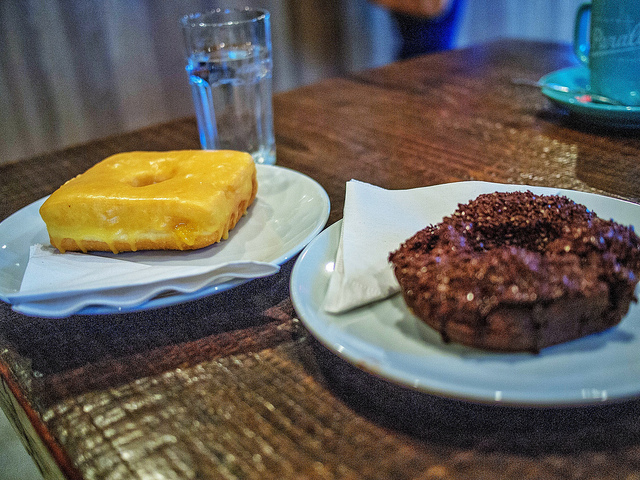How many donuts are there? There are two delicious-looking donuts in the image, one with a shiny, golden-yellow glaze and the other coated in a generous layer of chocolate sprinkles. 